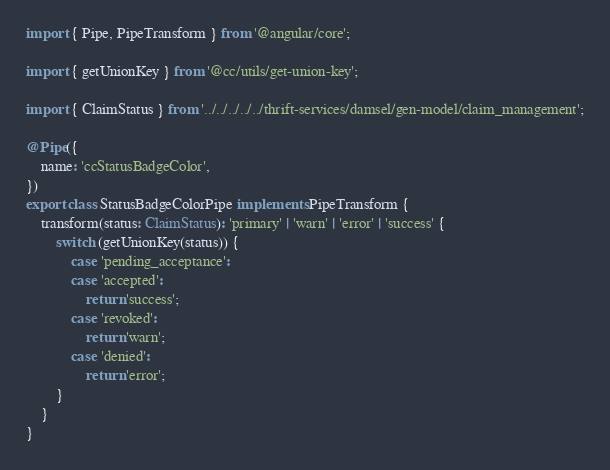<code> <loc_0><loc_0><loc_500><loc_500><_TypeScript_>import { Pipe, PipeTransform } from '@angular/core';

import { getUnionKey } from '@cc/utils/get-union-key';

import { ClaimStatus } from '../../../../../thrift-services/damsel/gen-model/claim_management';

@Pipe({
    name: 'ccStatusBadgeColor',
})
export class StatusBadgeColorPipe implements PipeTransform {
    transform(status: ClaimStatus): 'primary' | 'warn' | 'error' | 'success' {
        switch (getUnionKey(status)) {
            case 'pending_acceptance':
            case 'accepted':
                return 'success';
            case 'revoked':
                return 'warn';
            case 'denied':
                return 'error';
        }
    }
}
</code> 